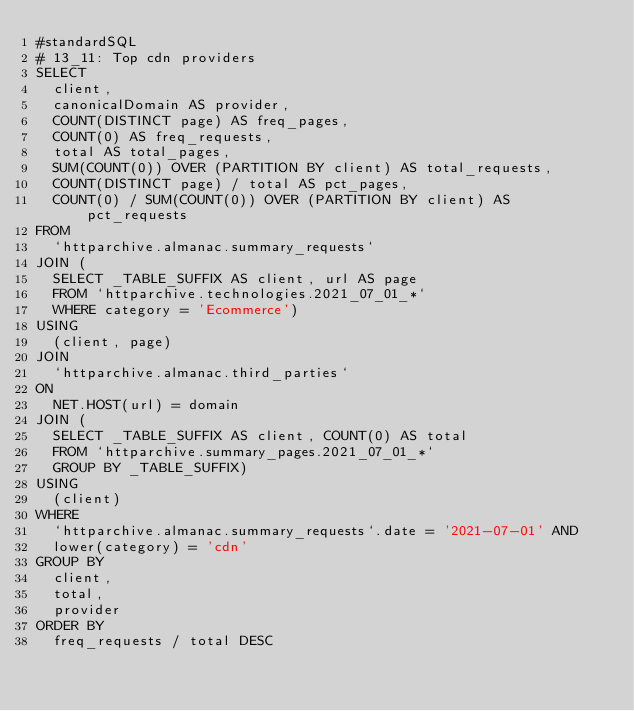<code> <loc_0><loc_0><loc_500><loc_500><_SQL_>#standardSQL
# 13_11: Top cdn providers
SELECT
  client,
  canonicalDomain AS provider,
  COUNT(DISTINCT page) AS freq_pages,
  COUNT(0) AS freq_requests,
  total AS total_pages,
  SUM(COUNT(0)) OVER (PARTITION BY client) AS total_requests,
  COUNT(DISTINCT page) / total AS pct_pages,
  COUNT(0) / SUM(COUNT(0)) OVER (PARTITION BY client) AS pct_requests
FROM
  `httparchive.almanac.summary_requests`
JOIN (
  SELECT _TABLE_SUFFIX AS client, url AS page
  FROM `httparchive.technologies.2021_07_01_*`
  WHERE category = 'Ecommerce')
USING
  (client, page)
JOIN
  `httparchive.almanac.third_parties`
ON
  NET.HOST(url) = domain
JOIN (
  SELECT _TABLE_SUFFIX AS client, COUNT(0) AS total
  FROM `httparchive.summary_pages.2021_07_01_*`
  GROUP BY _TABLE_SUFFIX)
USING
  (client)
WHERE
  `httparchive.almanac.summary_requests`.date = '2021-07-01' AND
  lower(category) = 'cdn'
GROUP BY
  client,
  total,
  provider
ORDER BY
  freq_requests / total DESC
</code> 